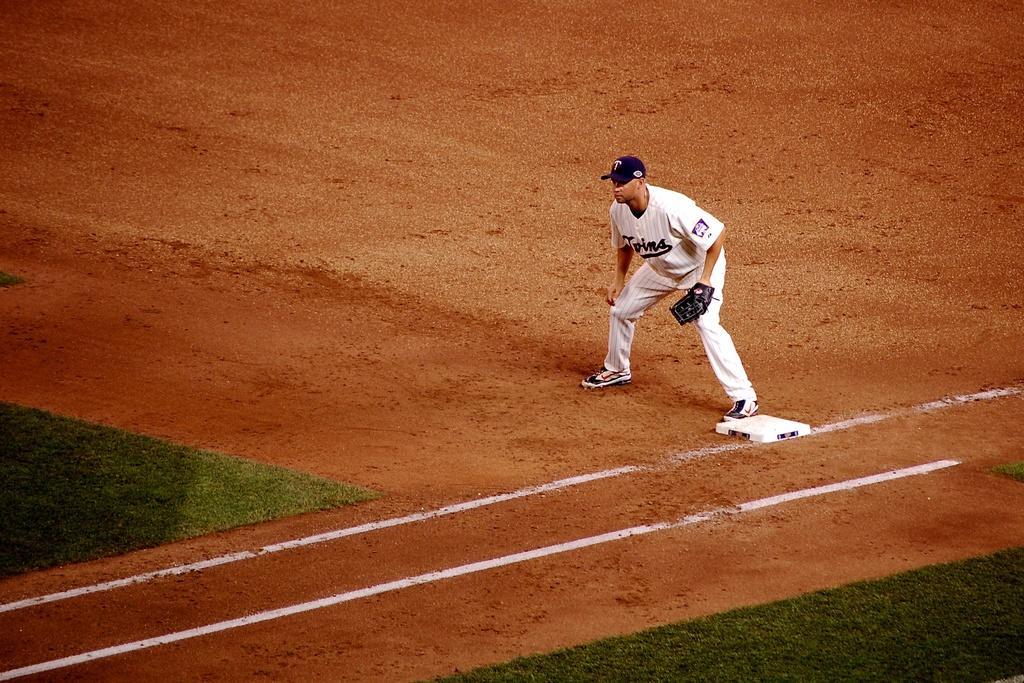In one or two sentences, can you explain what this image depicts? In this picture we can see a person wearing a cap and a glove on his hand. He is standing on the ground. We can see some grass, white object and a few white lines on the ground. 